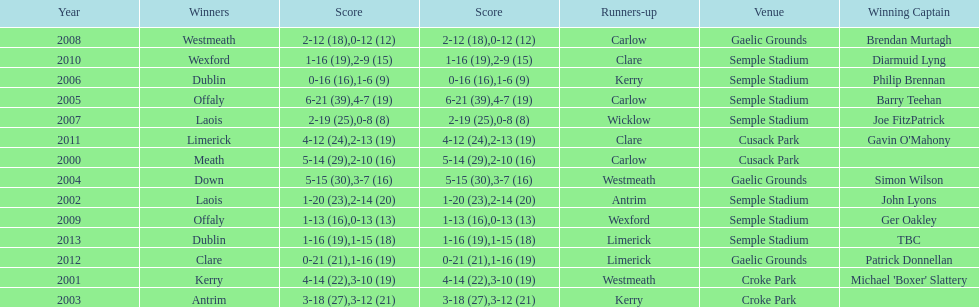Who was the initial victorious captain? Michael 'Boxer' Slattery. 